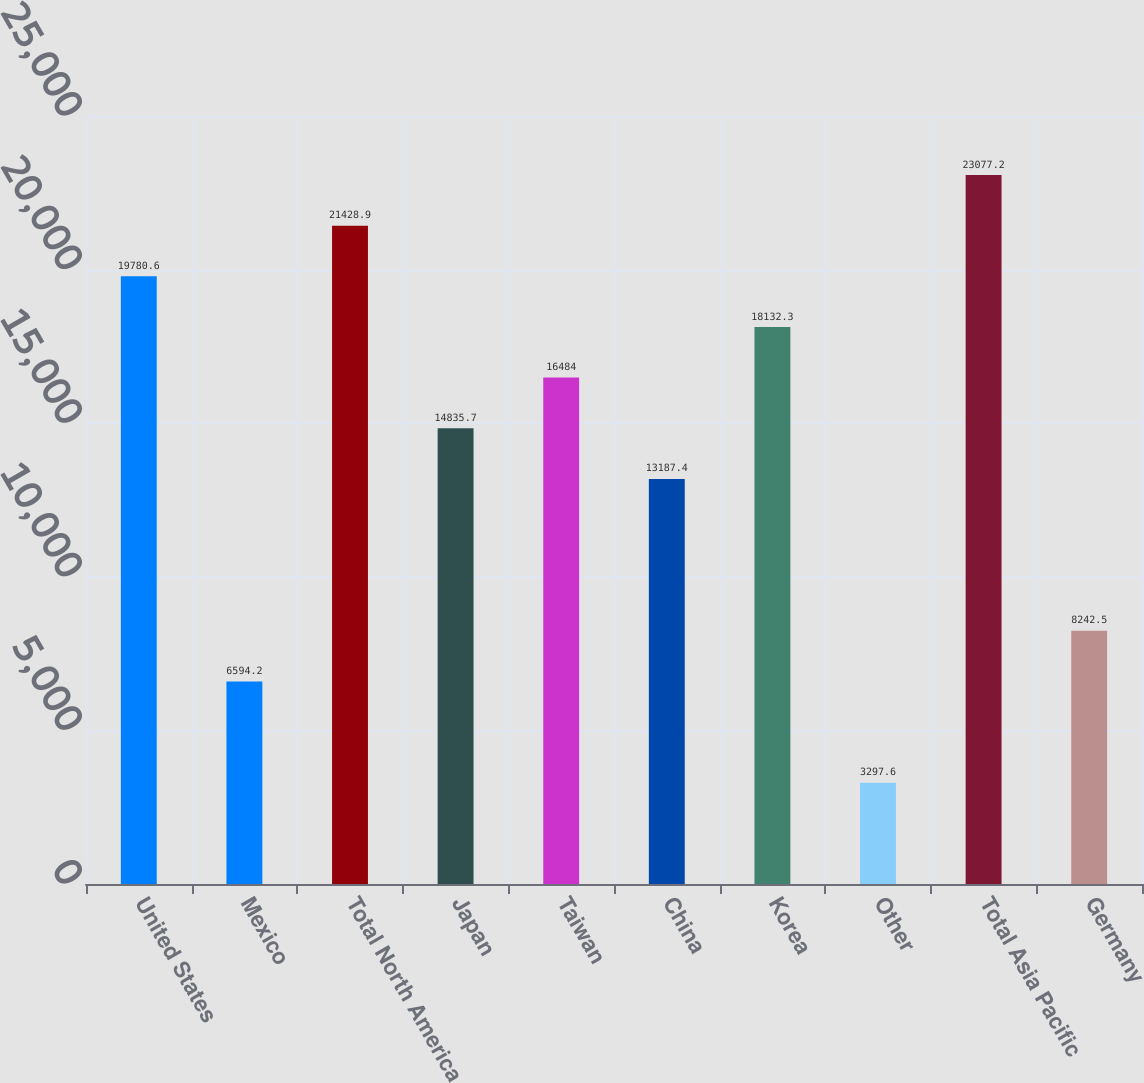<chart> <loc_0><loc_0><loc_500><loc_500><bar_chart><fcel>United States<fcel>Mexico<fcel>Total North America<fcel>Japan<fcel>Taiwan<fcel>China<fcel>Korea<fcel>Other<fcel>Total Asia Pacific<fcel>Germany<nl><fcel>19780.6<fcel>6594.2<fcel>21428.9<fcel>14835.7<fcel>16484<fcel>13187.4<fcel>18132.3<fcel>3297.6<fcel>23077.2<fcel>8242.5<nl></chart> 